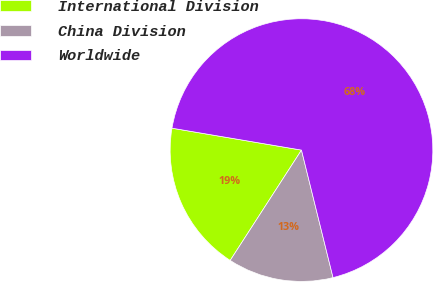Convert chart to OTSL. <chart><loc_0><loc_0><loc_500><loc_500><pie_chart><fcel>International Division<fcel>China Division<fcel>Worldwide<nl><fcel>18.54%<fcel>12.99%<fcel>68.47%<nl></chart> 